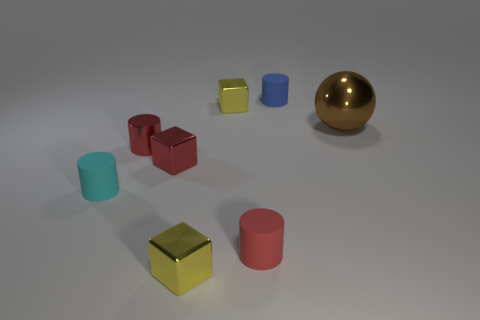Are there fewer yellow shiny cubes that are behind the big shiny sphere than small cyan matte cylinders behind the metallic cylinder?
Provide a succinct answer. No. There is a ball; are there any tiny yellow things in front of it?
Your answer should be compact. Yes. How many things are either metal objects that are behind the red metal cylinder or small blue rubber cylinders that are behind the red matte cylinder?
Give a very brief answer. 3. How many tiny cylinders have the same color as the big object?
Make the answer very short. 0. The metal object that is the same shape as the tiny cyan rubber thing is what color?
Provide a succinct answer. Red. What shape is the tiny matte object that is right of the shiny cylinder and in front of the large shiny thing?
Make the answer very short. Cylinder. Are there more tiny objects than tiny rubber objects?
Provide a short and direct response. Yes. What is the material of the red cube?
Your answer should be compact. Metal. Is there any other thing that is the same size as the red metal block?
Ensure brevity in your answer.  Yes. What is the size of the cyan thing that is the same shape as the tiny blue thing?
Your response must be concise. Small. 